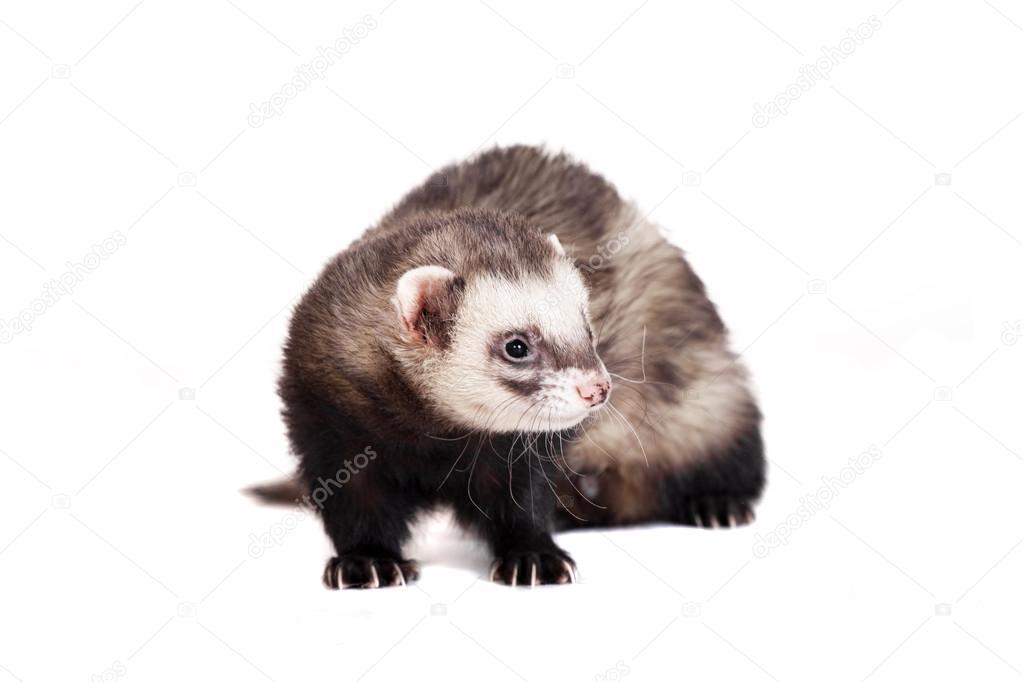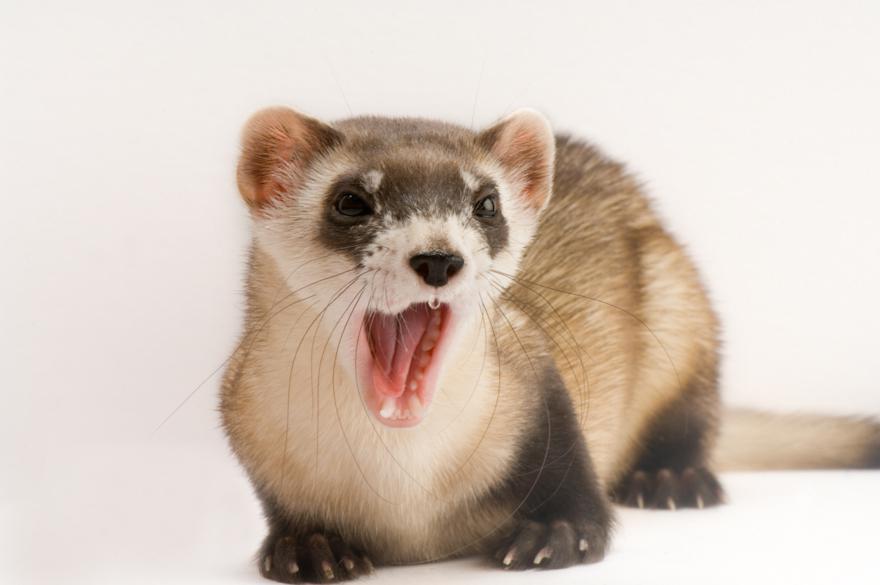The first image is the image on the left, the second image is the image on the right. Examine the images to the left and right. Is the description "All of the ferrets are visible as a full body shot." accurate? Answer yes or no. Yes. 